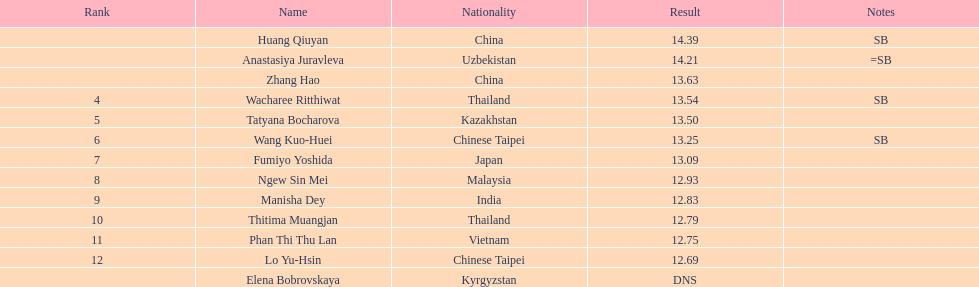Help me parse the entirety of this table. {'header': ['Rank', 'Name', 'Nationality', 'Result', 'Notes'], 'rows': [['', 'Huang Qiuyan', 'China', '14.39', 'SB'], ['', 'Anastasiya Juravleva', 'Uzbekistan', '14.21', '=SB'], ['', 'Zhang Hao', 'China', '13.63', ''], ['4', 'Wacharee Ritthiwat', 'Thailand', '13.54', 'SB'], ['5', 'Tatyana Bocharova', 'Kazakhstan', '13.50', ''], ['6', 'Wang Kuo-Huei', 'Chinese Taipei', '13.25', 'SB'], ['7', 'Fumiyo Yoshida', 'Japan', '13.09', ''], ['8', 'Ngew Sin Mei', 'Malaysia', '12.93', ''], ['9', 'Manisha Dey', 'India', '12.83', ''], ['10', 'Thitima Muangjan', 'Thailand', '12.79', ''], ['11', 'Phan Thi Thu Lan', 'Vietnam', '12.75', ''], ['12', 'Lo Yu-Hsin', 'Chinese Taipei', '12.69', ''], ['', 'Elena Bobrovskaya', 'Kyrgyzstan', 'DNS', '']]} Which country came in first? China. 